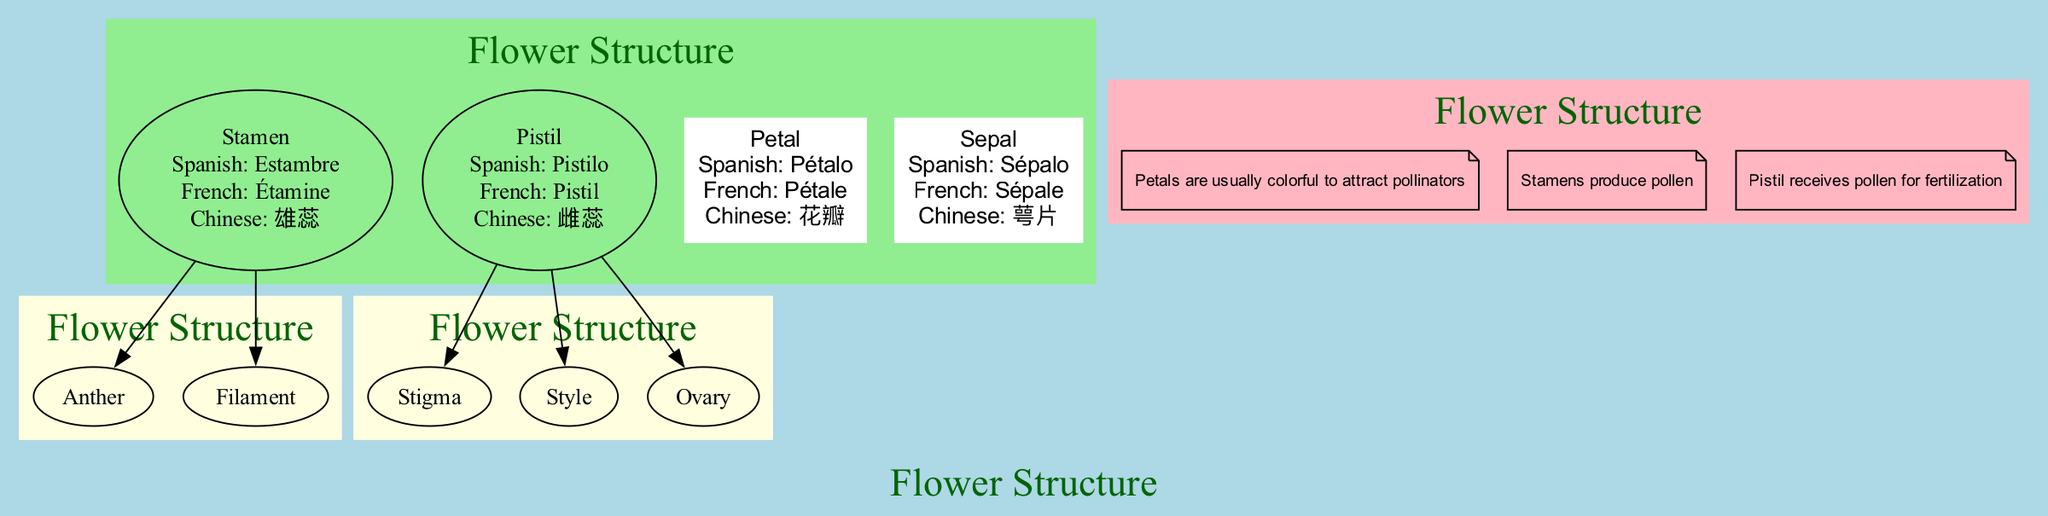What is the Spanish term for "Petal"? The diagram includes translations for each main part. In the section for the "Petal," the Spanish translation is provided as "Pétalo."
Answer: Pétalo How many sub-parts does the "Stamen" have? In the diagram, the "Stamen" section includes two sub-parts listed: "Anther" and "Filament." Therefore, the total number of sub-parts is 2.
Answer: 2 What does the "Pistil" receive? According to the notes section of the diagram, the "Pistil" receives pollen, which is crucial for the process of fertilization.
Answer: Pollen What part is typically colorful to attract pollinators? The notes specify that "Petals are usually colorful to attract pollinators," indicating that petals serve this function.
Answer: Petals Which part produces pollen? The notes state that "Stamens produce pollen," making it clear that this part of the flower is responsible for pollen production.
Answer: Stamens What are the three sub-parts of the "Pistil"? The sub-parts of the "Pistil" are "Stigma," "Style," and "Ovary." This information can be derived from the diagram where the "Pistil" is defined with its three components.
Answer: Stigma, Style, Ovary How many main parts does the flower have? By counting the entries under "main_parts" in the diagram, there are four main parts listed: "Petal," "Stamen," "Pistil," and "Sepal.”
Answer: 4 What is the French term for "Stamen"? The translation for "Stamen" is provided in the diagram as "Étamine" in the French section, indicating the term used in that language.
Answer: Étamine What part is labeled "雄蕊" in Chinese? The diagram lists "雄蕊" as the translation for "Stamen," indicating the respective term provided in Chinese for this part of the flower.
Answer: Stamen 